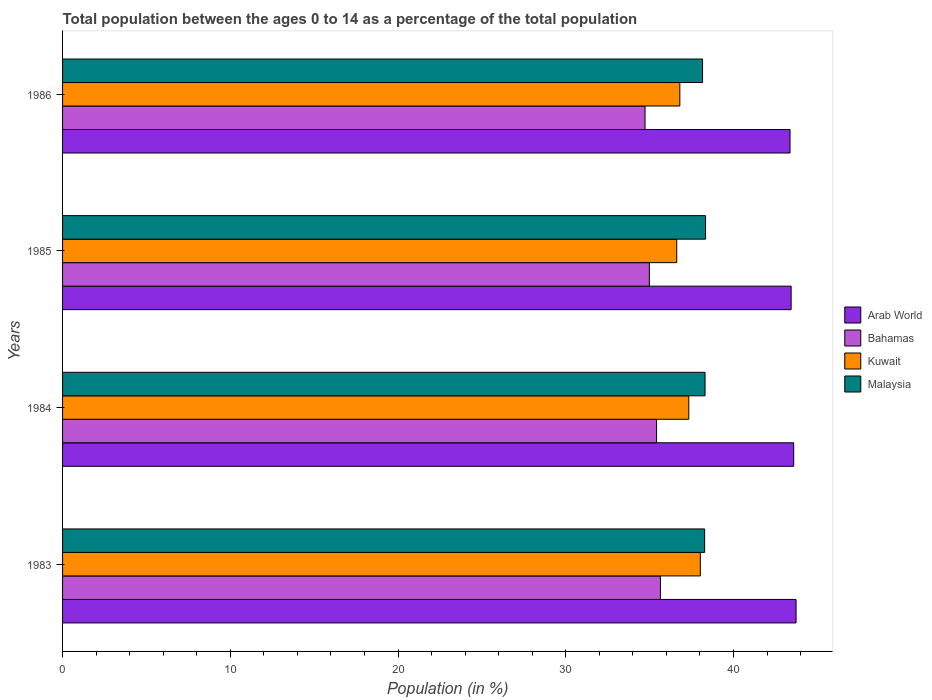How many different coloured bars are there?
Your answer should be very brief. 4. Are the number of bars per tick equal to the number of legend labels?
Provide a succinct answer. Yes. How many bars are there on the 4th tick from the bottom?
Make the answer very short. 4. What is the label of the 3rd group of bars from the top?
Offer a terse response. 1984. In how many cases, is the number of bars for a given year not equal to the number of legend labels?
Your response must be concise. 0. What is the percentage of the population ages 0 to 14 in Kuwait in 1985?
Make the answer very short. 36.62. Across all years, what is the maximum percentage of the population ages 0 to 14 in Malaysia?
Give a very brief answer. 38.34. Across all years, what is the minimum percentage of the population ages 0 to 14 in Arab World?
Give a very brief answer. 43.37. In which year was the percentage of the population ages 0 to 14 in Bahamas maximum?
Offer a very short reply. 1983. In which year was the percentage of the population ages 0 to 14 in Kuwait minimum?
Ensure brevity in your answer.  1985. What is the total percentage of the population ages 0 to 14 in Bahamas in the graph?
Keep it short and to the point. 140.77. What is the difference between the percentage of the population ages 0 to 14 in Malaysia in 1984 and that in 1985?
Keep it short and to the point. -0.03. What is the difference between the percentage of the population ages 0 to 14 in Kuwait in 1985 and the percentage of the population ages 0 to 14 in Malaysia in 1984?
Your response must be concise. -1.69. What is the average percentage of the population ages 0 to 14 in Malaysia per year?
Provide a short and direct response. 38.27. In the year 1983, what is the difference between the percentage of the population ages 0 to 14 in Kuwait and percentage of the population ages 0 to 14 in Malaysia?
Provide a succinct answer. -0.25. What is the ratio of the percentage of the population ages 0 to 14 in Kuwait in 1983 to that in 1986?
Your response must be concise. 1.03. What is the difference between the highest and the second highest percentage of the population ages 0 to 14 in Arab World?
Your answer should be very brief. 0.14. What is the difference between the highest and the lowest percentage of the population ages 0 to 14 in Kuwait?
Your response must be concise. 1.41. In how many years, is the percentage of the population ages 0 to 14 in Malaysia greater than the average percentage of the population ages 0 to 14 in Malaysia taken over all years?
Your answer should be compact. 3. What does the 1st bar from the top in 1985 represents?
Keep it short and to the point. Malaysia. What does the 1st bar from the bottom in 1983 represents?
Provide a succinct answer. Arab World. How many bars are there?
Keep it short and to the point. 16. Are all the bars in the graph horizontal?
Your answer should be very brief. Yes. Does the graph contain any zero values?
Ensure brevity in your answer.  No. Where does the legend appear in the graph?
Your response must be concise. Center right. How many legend labels are there?
Ensure brevity in your answer.  4. What is the title of the graph?
Make the answer very short. Total population between the ages 0 to 14 as a percentage of the total population. Does "Sub-Saharan Africa (developing only)" appear as one of the legend labels in the graph?
Offer a very short reply. No. What is the label or title of the X-axis?
Provide a succinct answer. Population (in %). What is the Population (in %) in Arab World in 1983?
Your answer should be very brief. 43.73. What is the Population (in %) in Bahamas in 1983?
Your answer should be very brief. 35.64. What is the Population (in %) of Kuwait in 1983?
Offer a very short reply. 38.03. What is the Population (in %) of Malaysia in 1983?
Give a very brief answer. 38.28. What is the Population (in %) in Arab World in 1984?
Provide a short and direct response. 43.59. What is the Population (in %) in Bahamas in 1984?
Ensure brevity in your answer.  35.42. What is the Population (in %) of Kuwait in 1984?
Offer a terse response. 37.34. What is the Population (in %) of Malaysia in 1984?
Your response must be concise. 38.31. What is the Population (in %) of Arab World in 1985?
Your answer should be compact. 43.44. What is the Population (in %) of Bahamas in 1985?
Provide a short and direct response. 34.99. What is the Population (in %) in Kuwait in 1985?
Give a very brief answer. 36.62. What is the Population (in %) of Malaysia in 1985?
Give a very brief answer. 38.34. What is the Population (in %) in Arab World in 1986?
Your answer should be compact. 43.37. What is the Population (in %) in Bahamas in 1986?
Provide a short and direct response. 34.73. What is the Population (in %) in Kuwait in 1986?
Offer a terse response. 36.8. What is the Population (in %) of Malaysia in 1986?
Provide a short and direct response. 38.16. Across all years, what is the maximum Population (in %) of Arab World?
Offer a terse response. 43.73. Across all years, what is the maximum Population (in %) in Bahamas?
Provide a succinct answer. 35.64. Across all years, what is the maximum Population (in %) of Kuwait?
Provide a succinct answer. 38.03. Across all years, what is the maximum Population (in %) in Malaysia?
Ensure brevity in your answer.  38.34. Across all years, what is the minimum Population (in %) in Arab World?
Ensure brevity in your answer.  43.37. Across all years, what is the minimum Population (in %) in Bahamas?
Make the answer very short. 34.73. Across all years, what is the minimum Population (in %) of Kuwait?
Provide a succinct answer. 36.62. Across all years, what is the minimum Population (in %) in Malaysia?
Offer a very short reply. 38.16. What is the total Population (in %) in Arab World in the graph?
Offer a terse response. 174.14. What is the total Population (in %) of Bahamas in the graph?
Ensure brevity in your answer.  140.77. What is the total Population (in %) of Kuwait in the graph?
Provide a short and direct response. 148.78. What is the total Population (in %) in Malaysia in the graph?
Your response must be concise. 153.08. What is the difference between the Population (in %) in Arab World in 1983 and that in 1984?
Offer a very short reply. 0.14. What is the difference between the Population (in %) in Bahamas in 1983 and that in 1984?
Give a very brief answer. 0.23. What is the difference between the Population (in %) in Kuwait in 1983 and that in 1984?
Keep it short and to the point. 0.69. What is the difference between the Population (in %) in Malaysia in 1983 and that in 1984?
Offer a terse response. -0.03. What is the difference between the Population (in %) in Arab World in 1983 and that in 1985?
Ensure brevity in your answer.  0.29. What is the difference between the Population (in %) in Bahamas in 1983 and that in 1985?
Give a very brief answer. 0.66. What is the difference between the Population (in %) of Kuwait in 1983 and that in 1985?
Give a very brief answer. 1.41. What is the difference between the Population (in %) in Malaysia in 1983 and that in 1985?
Your response must be concise. -0.06. What is the difference between the Population (in %) in Arab World in 1983 and that in 1986?
Your answer should be compact. 0.36. What is the difference between the Population (in %) in Bahamas in 1983 and that in 1986?
Keep it short and to the point. 0.92. What is the difference between the Population (in %) of Kuwait in 1983 and that in 1986?
Provide a short and direct response. 1.22. What is the difference between the Population (in %) of Malaysia in 1983 and that in 1986?
Your answer should be compact. 0.12. What is the difference between the Population (in %) in Arab World in 1984 and that in 1985?
Offer a very short reply. 0.15. What is the difference between the Population (in %) of Bahamas in 1984 and that in 1985?
Your answer should be very brief. 0.43. What is the difference between the Population (in %) in Kuwait in 1984 and that in 1985?
Your response must be concise. 0.72. What is the difference between the Population (in %) of Malaysia in 1984 and that in 1985?
Offer a terse response. -0.03. What is the difference between the Population (in %) of Arab World in 1984 and that in 1986?
Provide a succinct answer. 0.22. What is the difference between the Population (in %) of Bahamas in 1984 and that in 1986?
Your answer should be very brief. 0.69. What is the difference between the Population (in %) in Kuwait in 1984 and that in 1986?
Your answer should be compact. 0.53. What is the difference between the Population (in %) in Malaysia in 1984 and that in 1986?
Your response must be concise. 0.15. What is the difference between the Population (in %) of Arab World in 1985 and that in 1986?
Your response must be concise. 0.07. What is the difference between the Population (in %) of Bahamas in 1985 and that in 1986?
Offer a terse response. 0.26. What is the difference between the Population (in %) in Kuwait in 1985 and that in 1986?
Ensure brevity in your answer.  -0.18. What is the difference between the Population (in %) of Malaysia in 1985 and that in 1986?
Your answer should be very brief. 0.18. What is the difference between the Population (in %) of Arab World in 1983 and the Population (in %) of Bahamas in 1984?
Provide a succinct answer. 8.32. What is the difference between the Population (in %) in Arab World in 1983 and the Population (in %) in Kuwait in 1984?
Your answer should be very brief. 6.4. What is the difference between the Population (in %) of Arab World in 1983 and the Population (in %) of Malaysia in 1984?
Your response must be concise. 5.43. What is the difference between the Population (in %) of Bahamas in 1983 and the Population (in %) of Kuwait in 1984?
Offer a terse response. -1.69. What is the difference between the Population (in %) of Bahamas in 1983 and the Population (in %) of Malaysia in 1984?
Give a very brief answer. -2.66. What is the difference between the Population (in %) in Kuwait in 1983 and the Population (in %) in Malaysia in 1984?
Give a very brief answer. -0.28. What is the difference between the Population (in %) in Arab World in 1983 and the Population (in %) in Bahamas in 1985?
Your answer should be compact. 8.75. What is the difference between the Population (in %) of Arab World in 1983 and the Population (in %) of Kuwait in 1985?
Keep it short and to the point. 7.12. What is the difference between the Population (in %) of Arab World in 1983 and the Population (in %) of Malaysia in 1985?
Offer a very short reply. 5.4. What is the difference between the Population (in %) in Bahamas in 1983 and the Population (in %) in Kuwait in 1985?
Provide a succinct answer. -0.97. What is the difference between the Population (in %) of Bahamas in 1983 and the Population (in %) of Malaysia in 1985?
Your answer should be very brief. -2.69. What is the difference between the Population (in %) of Kuwait in 1983 and the Population (in %) of Malaysia in 1985?
Offer a terse response. -0.31. What is the difference between the Population (in %) of Arab World in 1983 and the Population (in %) of Bahamas in 1986?
Offer a terse response. 9. What is the difference between the Population (in %) of Arab World in 1983 and the Population (in %) of Kuwait in 1986?
Offer a very short reply. 6.93. What is the difference between the Population (in %) in Arab World in 1983 and the Population (in %) in Malaysia in 1986?
Provide a succinct answer. 5.58. What is the difference between the Population (in %) in Bahamas in 1983 and the Population (in %) in Kuwait in 1986?
Ensure brevity in your answer.  -1.16. What is the difference between the Population (in %) in Bahamas in 1983 and the Population (in %) in Malaysia in 1986?
Ensure brevity in your answer.  -2.51. What is the difference between the Population (in %) of Kuwait in 1983 and the Population (in %) of Malaysia in 1986?
Make the answer very short. -0.13. What is the difference between the Population (in %) of Arab World in 1984 and the Population (in %) of Bahamas in 1985?
Offer a very short reply. 8.61. What is the difference between the Population (in %) of Arab World in 1984 and the Population (in %) of Kuwait in 1985?
Your answer should be very brief. 6.97. What is the difference between the Population (in %) in Arab World in 1984 and the Population (in %) in Malaysia in 1985?
Provide a succinct answer. 5.25. What is the difference between the Population (in %) of Bahamas in 1984 and the Population (in %) of Kuwait in 1985?
Give a very brief answer. -1.2. What is the difference between the Population (in %) of Bahamas in 1984 and the Population (in %) of Malaysia in 1985?
Offer a terse response. -2.92. What is the difference between the Population (in %) in Kuwait in 1984 and the Population (in %) in Malaysia in 1985?
Ensure brevity in your answer.  -1. What is the difference between the Population (in %) in Arab World in 1984 and the Population (in %) in Bahamas in 1986?
Provide a succinct answer. 8.86. What is the difference between the Population (in %) in Arab World in 1984 and the Population (in %) in Kuwait in 1986?
Your response must be concise. 6.79. What is the difference between the Population (in %) in Arab World in 1984 and the Population (in %) in Malaysia in 1986?
Your answer should be compact. 5.43. What is the difference between the Population (in %) of Bahamas in 1984 and the Population (in %) of Kuwait in 1986?
Provide a short and direct response. -1.39. What is the difference between the Population (in %) in Bahamas in 1984 and the Population (in %) in Malaysia in 1986?
Offer a terse response. -2.74. What is the difference between the Population (in %) of Kuwait in 1984 and the Population (in %) of Malaysia in 1986?
Offer a very short reply. -0.82. What is the difference between the Population (in %) in Arab World in 1985 and the Population (in %) in Bahamas in 1986?
Your response must be concise. 8.71. What is the difference between the Population (in %) of Arab World in 1985 and the Population (in %) of Kuwait in 1986?
Offer a terse response. 6.64. What is the difference between the Population (in %) in Arab World in 1985 and the Population (in %) in Malaysia in 1986?
Your response must be concise. 5.28. What is the difference between the Population (in %) of Bahamas in 1985 and the Population (in %) of Kuwait in 1986?
Ensure brevity in your answer.  -1.82. What is the difference between the Population (in %) in Bahamas in 1985 and the Population (in %) in Malaysia in 1986?
Keep it short and to the point. -3.17. What is the difference between the Population (in %) of Kuwait in 1985 and the Population (in %) of Malaysia in 1986?
Provide a succinct answer. -1.54. What is the average Population (in %) in Arab World per year?
Provide a short and direct response. 43.53. What is the average Population (in %) of Bahamas per year?
Offer a terse response. 35.19. What is the average Population (in %) in Kuwait per year?
Give a very brief answer. 37.2. What is the average Population (in %) in Malaysia per year?
Your answer should be compact. 38.27. In the year 1983, what is the difference between the Population (in %) in Arab World and Population (in %) in Bahamas?
Make the answer very short. 8.09. In the year 1983, what is the difference between the Population (in %) in Arab World and Population (in %) in Kuwait?
Make the answer very short. 5.71. In the year 1983, what is the difference between the Population (in %) of Arab World and Population (in %) of Malaysia?
Make the answer very short. 5.45. In the year 1983, what is the difference between the Population (in %) in Bahamas and Population (in %) in Kuwait?
Provide a succinct answer. -2.38. In the year 1983, what is the difference between the Population (in %) in Bahamas and Population (in %) in Malaysia?
Your response must be concise. -2.64. In the year 1983, what is the difference between the Population (in %) in Kuwait and Population (in %) in Malaysia?
Offer a very short reply. -0.25. In the year 1984, what is the difference between the Population (in %) of Arab World and Population (in %) of Bahamas?
Make the answer very short. 8.17. In the year 1984, what is the difference between the Population (in %) of Arab World and Population (in %) of Kuwait?
Offer a very short reply. 6.25. In the year 1984, what is the difference between the Population (in %) in Arab World and Population (in %) in Malaysia?
Offer a terse response. 5.29. In the year 1984, what is the difference between the Population (in %) in Bahamas and Population (in %) in Kuwait?
Provide a succinct answer. -1.92. In the year 1984, what is the difference between the Population (in %) in Bahamas and Population (in %) in Malaysia?
Your answer should be compact. -2.89. In the year 1984, what is the difference between the Population (in %) of Kuwait and Population (in %) of Malaysia?
Your answer should be compact. -0.97. In the year 1985, what is the difference between the Population (in %) in Arab World and Population (in %) in Bahamas?
Your answer should be compact. 8.45. In the year 1985, what is the difference between the Population (in %) of Arab World and Population (in %) of Kuwait?
Give a very brief answer. 6.82. In the year 1985, what is the difference between the Population (in %) in Arab World and Population (in %) in Malaysia?
Your answer should be compact. 5.1. In the year 1985, what is the difference between the Population (in %) in Bahamas and Population (in %) in Kuwait?
Provide a succinct answer. -1.63. In the year 1985, what is the difference between the Population (in %) of Bahamas and Population (in %) of Malaysia?
Offer a very short reply. -3.35. In the year 1985, what is the difference between the Population (in %) of Kuwait and Population (in %) of Malaysia?
Give a very brief answer. -1.72. In the year 1986, what is the difference between the Population (in %) of Arab World and Population (in %) of Bahamas?
Your response must be concise. 8.64. In the year 1986, what is the difference between the Population (in %) of Arab World and Population (in %) of Kuwait?
Make the answer very short. 6.57. In the year 1986, what is the difference between the Population (in %) of Arab World and Population (in %) of Malaysia?
Your answer should be very brief. 5.22. In the year 1986, what is the difference between the Population (in %) of Bahamas and Population (in %) of Kuwait?
Your response must be concise. -2.07. In the year 1986, what is the difference between the Population (in %) of Bahamas and Population (in %) of Malaysia?
Make the answer very short. -3.43. In the year 1986, what is the difference between the Population (in %) in Kuwait and Population (in %) in Malaysia?
Your answer should be very brief. -1.35. What is the ratio of the Population (in %) of Bahamas in 1983 to that in 1984?
Make the answer very short. 1.01. What is the ratio of the Population (in %) in Kuwait in 1983 to that in 1984?
Offer a terse response. 1.02. What is the ratio of the Population (in %) of Arab World in 1983 to that in 1985?
Offer a terse response. 1.01. What is the ratio of the Population (in %) of Bahamas in 1983 to that in 1985?
Offer a terse response. 1.02. What is the ratio of the Population (in %) in Kuwait in 1983 to that in 1985?
Provide a succinct answer. 1.04. What is the ratio of the Population (in %) in Malaysia in 1983 to that in 1985?
Give a very brief answer. 1. What is the ratio of the Population (in %) of Arab World in 1983 to that in 1986?
Your answer should be compact. 1.01. What is the ratio of the Population (in %) of Bahamas in 1983 to that in 1986?
Give a very brief answer. 1.03. What is the ratio of the Population (in %) in Kuwait in 1983 to that in 1986?
Provide a succinct answer. 1.03. What is the ratio of the Population (in %) of Malaysia in 1983 to that in 1986?
Keep it short and to the point. 1. What is the ratio of the Population (in %) in Bahamas in 1984 to that in 1985?
Ensure brevity in your answer.  1.01. What is the ratio of the Population (in %) in Kuwait in 1984 to that in 1985?
Offer a terse response. 1.02. What is the ratio of the Population (in %) of Arab World in 1984 to that in 1986?
Give a very brief answer. 1. What is the ratio of the Population (in %) of Bahamas in 1984 to that in 1986?
Make the answer very short. 1.02. What is the ratio of the Population (in %) of Kuwait in 1984 to that in 1986?
Offer a terse response. 1.01. What is the ratio of the Population (in %) in Malaysia in 1984 to that in 1986?
Your answer should be very brief. 1. What is the ratio of the Population (in %) of Bahamas in 1985 to that in 1986?
Give a very brief answer. 1.01. What is the ratio of the Population (in %) in Malaysia in 1985 to that in 1986?
Make the answer very short. 1. What is the difference between the highest and the second highest Population (in %) in Arab World?
Provide a short and direct response. 0.14. What is the difference between the highest and the second highest Population (in %) in Bahamas?
Keep it short and to the point. 0.23. What is the difference between the highest and the second highest Population (in %) of Kuwait?
Offer a very short reply. 0.69. What is the difference between the highest and the second highest Population (in %) of Malaysia?
Offer a terse response. 0.03. What is the difference between the highest and the lowest Population (in %) of Arab World?
Make the answer very short. 0.36. What is the difference between the highest and the lowest Population (in %) of Bahamas?
Your answer should be very brief. 0.92. What is the difference between the highest and the lowest Population (in %) in Kuwait?
Keep it short and to the point. 1.41. What is the difference between the highest and the lowest Population (in %) in Malaysia?
Ensure brevity in your answer.  0.18. 